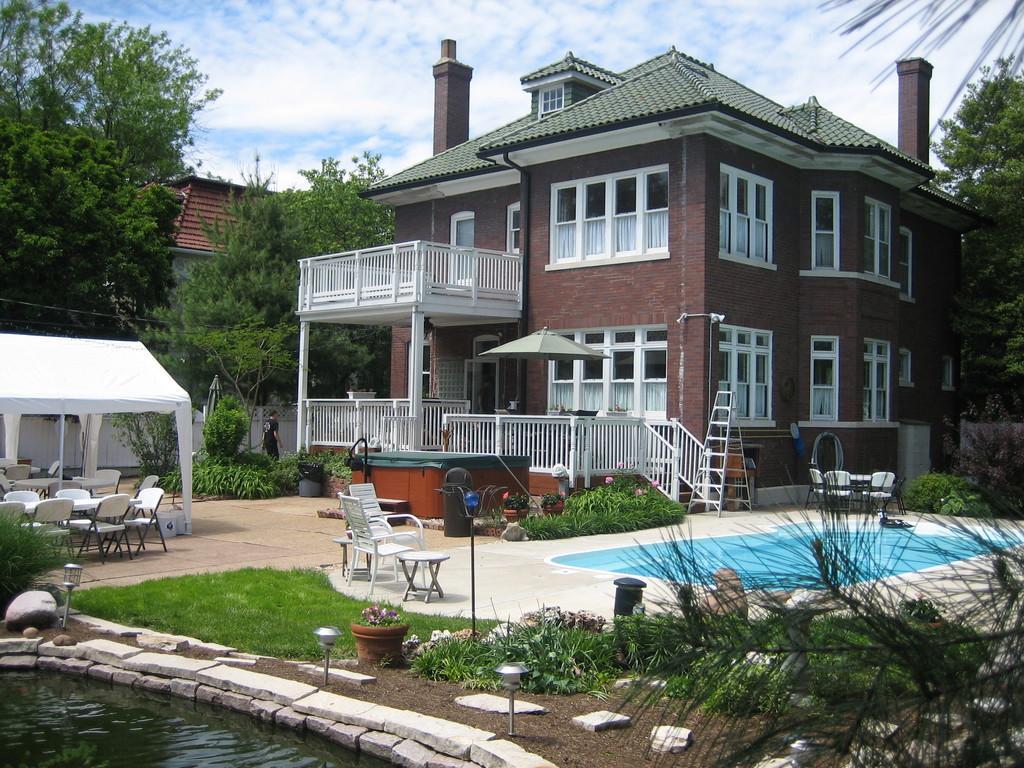How would you summarize this image in a sentence or two? In the image there is a pound with water, plants, trees, chairs, tent, ladder, swimming pool and many other items. And there is a building with walls, windows, roofs, pillars and railings. In the background there are many trees. At the top of the image there is a sky.  